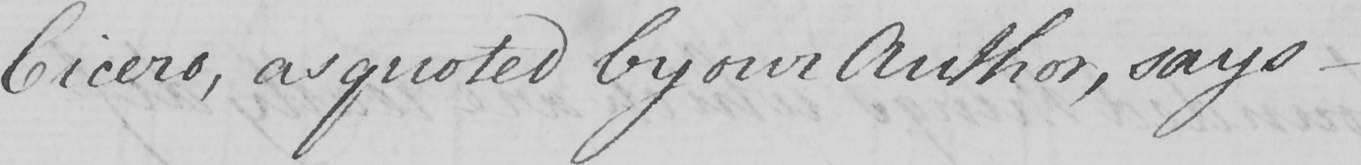Can you read and transcribe this handwriting? Cicero , as quoted by our Author , says  _ 